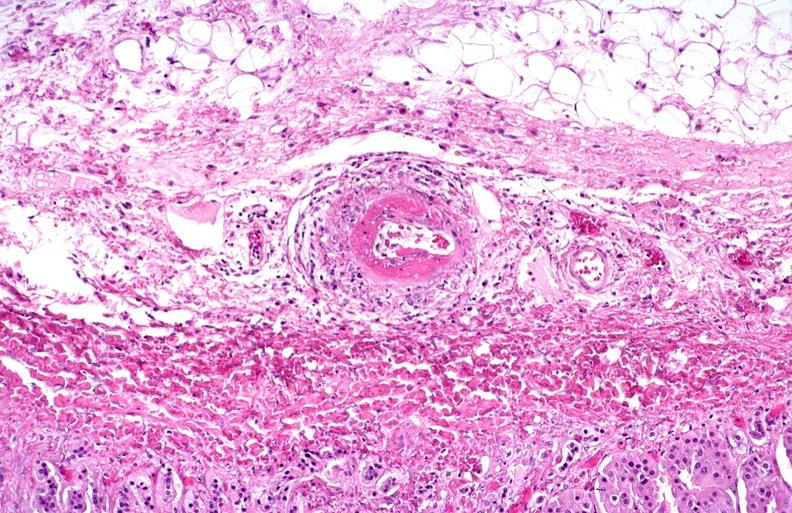s surface present?
Answer the question using a single word or phrase. No 